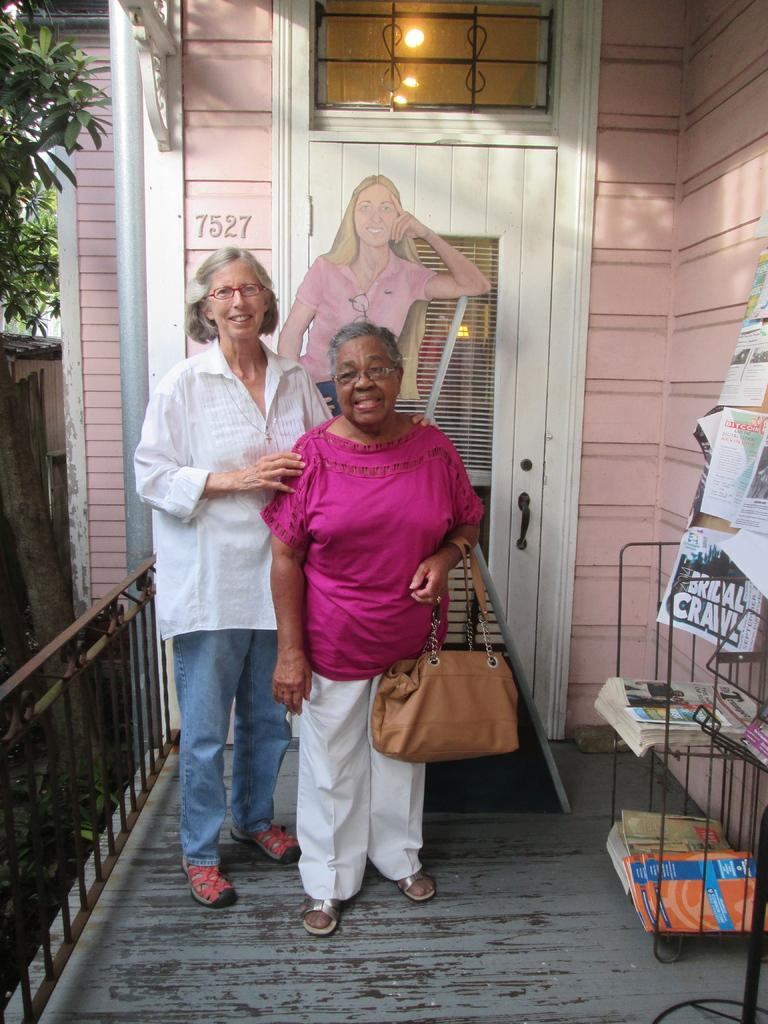How many people are in the image? There are two women in the image. What are the women doing in the image? The women are posing for a photo. Where are the women standing in the image? The women are standing in front of a door. What is one of the women holding in the image? One of the women is holding a bag. What type of donkey can be seen in the image? There is no donkey present in the image. Can you describe the monkey's interaction with the women in the image? There is no monkey present in the image. 